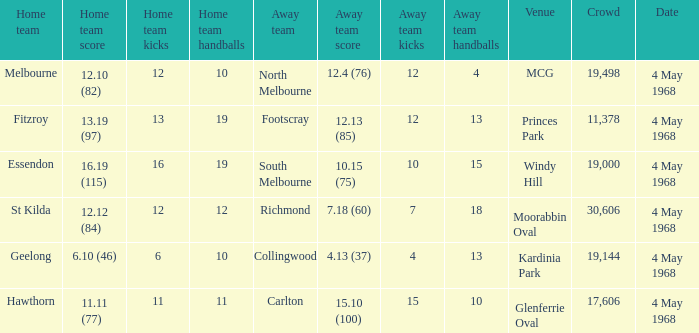How big was the crowd of the team that scored 4.13 (37)? 19144.0. 